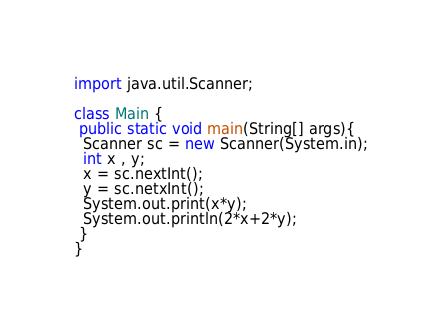Convert code to text. <code><loc_0><loc_0><loc_500><loc_500><_Java_>import java.util.Scanner;

class Main {
 public static void main(String[] args){
  Scanner sc = new Scanner(System.in);
  int x , y;
  x = sc.nextInt();
  y = sc.netxInt();
  System.out.print(x*y);
  System.out.println(2*x+2*y);
 }
}</code> 